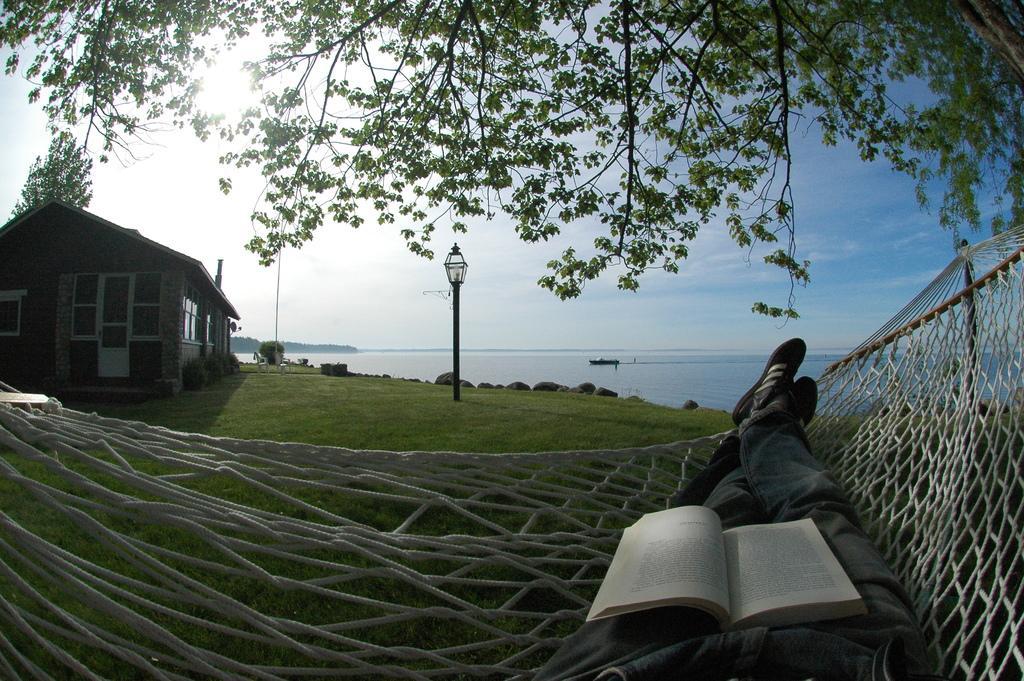Please provide a concise description of this image. In this image, we can see human legs and book on the net. Background we can see grass, house, door, windows, wall, plants, pole with light, sea and sky. Top of the image, we can see tree stems and leaves. 